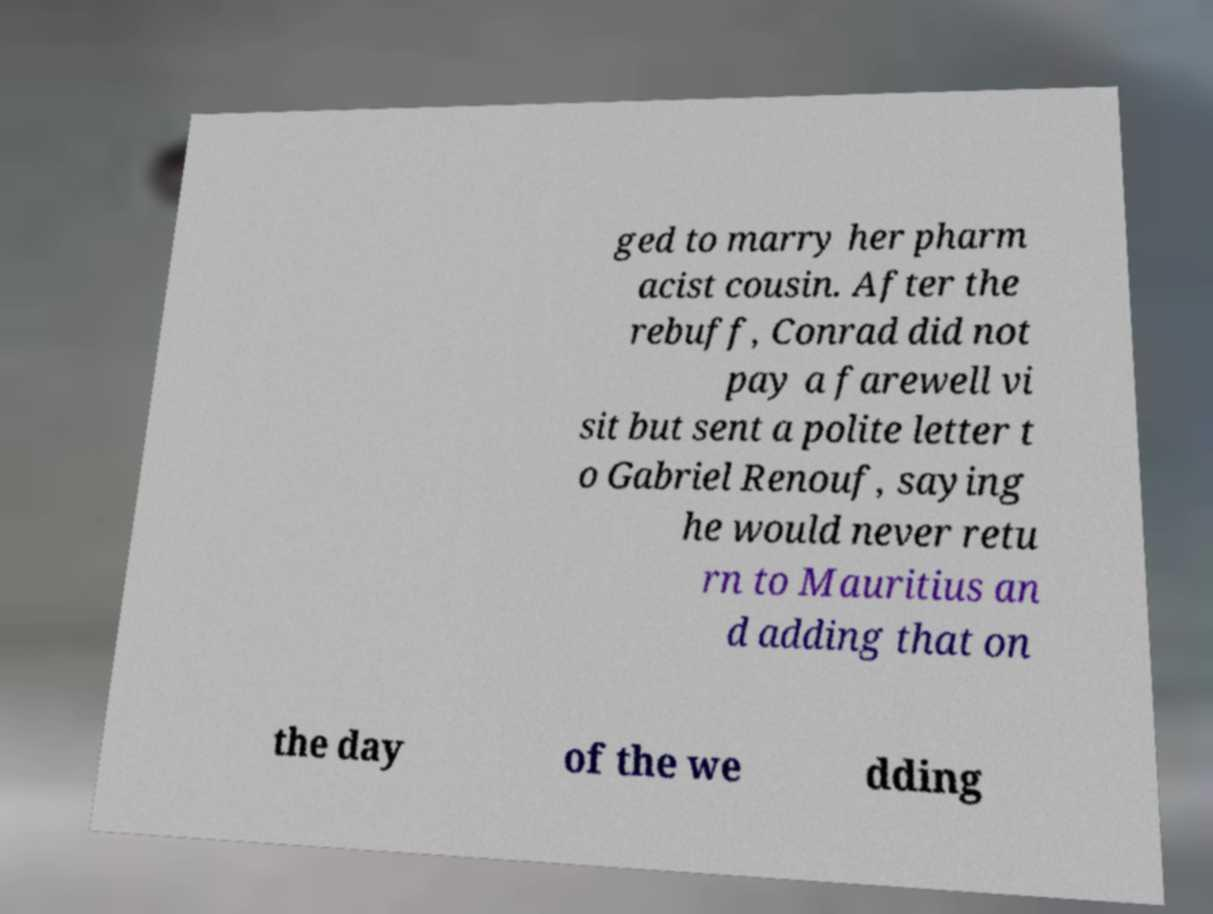Could you extract and type out the text from this image? ged to marry her pharm acist cousin. After the rebuff, Conrad did not pay a farewell vi sit but sent a polite letter t o Gabriel Renouf, saying he would never retu rn to Mauritius an d adding that on the day of the we dding 